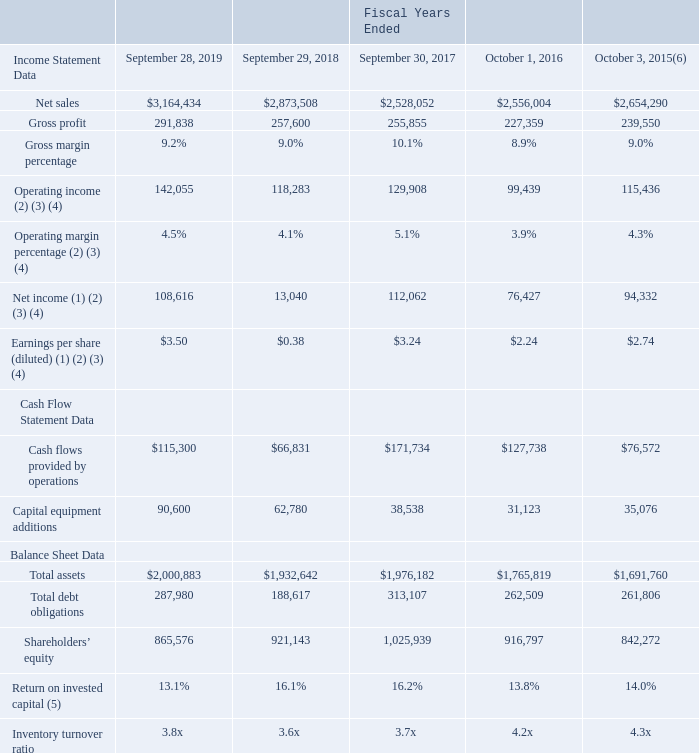ITEM 6. SELECTED FINANCIAL DATA
Financial Highlights (dollars in thousands, except per share amounts)
(1) During fiscal 2019, the Company recorded $7.0 million of special tax expense in accordance with regulations under U.S. Tax Reform, and reasserted that certain historical undistributed earnings of two foreign subsidiaries will be permanently reinvested, resulting in a $10.5 million benefit.
(2) During fiscal 2019, the Company recorded $1.7 million, $1.5 million net of taxes, in restructuring costs, which are included in operating income.
(3) During fiscal 2018, the Company recorded $85.9 million of non-recurring income tax expense due to the enactment of U.S. Tax Reform and paid a $13.5 million one-time non-executive employee bonus.
(4) During fiscal 2016, the Company recorded $7.0 million in restructuring costs and $5.2 million in selling and administrative expenses, which are included in operating income. The $7.0 million was largely related to the Company's closure of its manufacturing facility in Fremont, California, and the partial closure of its Livingston, Scotland facility. The $5.2 million was related to accelerated share-based compensation expense recorded pursuant to the retirement agreement with the Company's former Chief Executive Officer. During fiscal 2015 the Company recorded $1.7 million of restructuring costs, largely related to the Company's consolidation of its manufacturing facilities in Wisconsin, as well as its relocation of manufacturing operations from Juarez, Mexico to Guadalajara, Mexico.
(5) The Company defines return on invested capital ("ROIC"), a non-GAAP financial measure, as tax-effected operating income divided by average invested capital over a rolling five-quarter period. Invested capital is defined as equity plus debt, less cash and cash equivalents, as discussed in Part II, Item 7, "Management’s Discussion and Analysis of Financial Condition and Results of Operations - Return on Invested Capital ("ROIC") and Economic Return." For a reconciliation of ROIC and Economic Return to our financial statements that were prepared in accordance with GAAP, see Exhibit 99.1 to this annual report on Form 10-K.
(6) Fiscal 2015 included 53 weeks. All other periods presented included 52 weeks.
What was the amount of special tax expense in accordance with regulations under U.S. Tax Reform during Fiscal 2019?
Answer scale should be: million. 7.0. What was the net sales in 2015?
Answer scale should be: thousand. 2,654,290. Which years does the table provide information for the company's financial highlights? 2019, 2018, 2017, 2016, 2015. How many years did the gross margin percentage exceed 10%? 2017
Answer: 1. What was the change in the gross profit between 2015 and 2016?
Answer scale should be: thousand. 227,359-239,550
Answer: -12191. What was the percentage change in net income between 2018 and 2019?
Answer scale should be: percent. (108,616-13,040)/13,040
Answer: 732.94. 